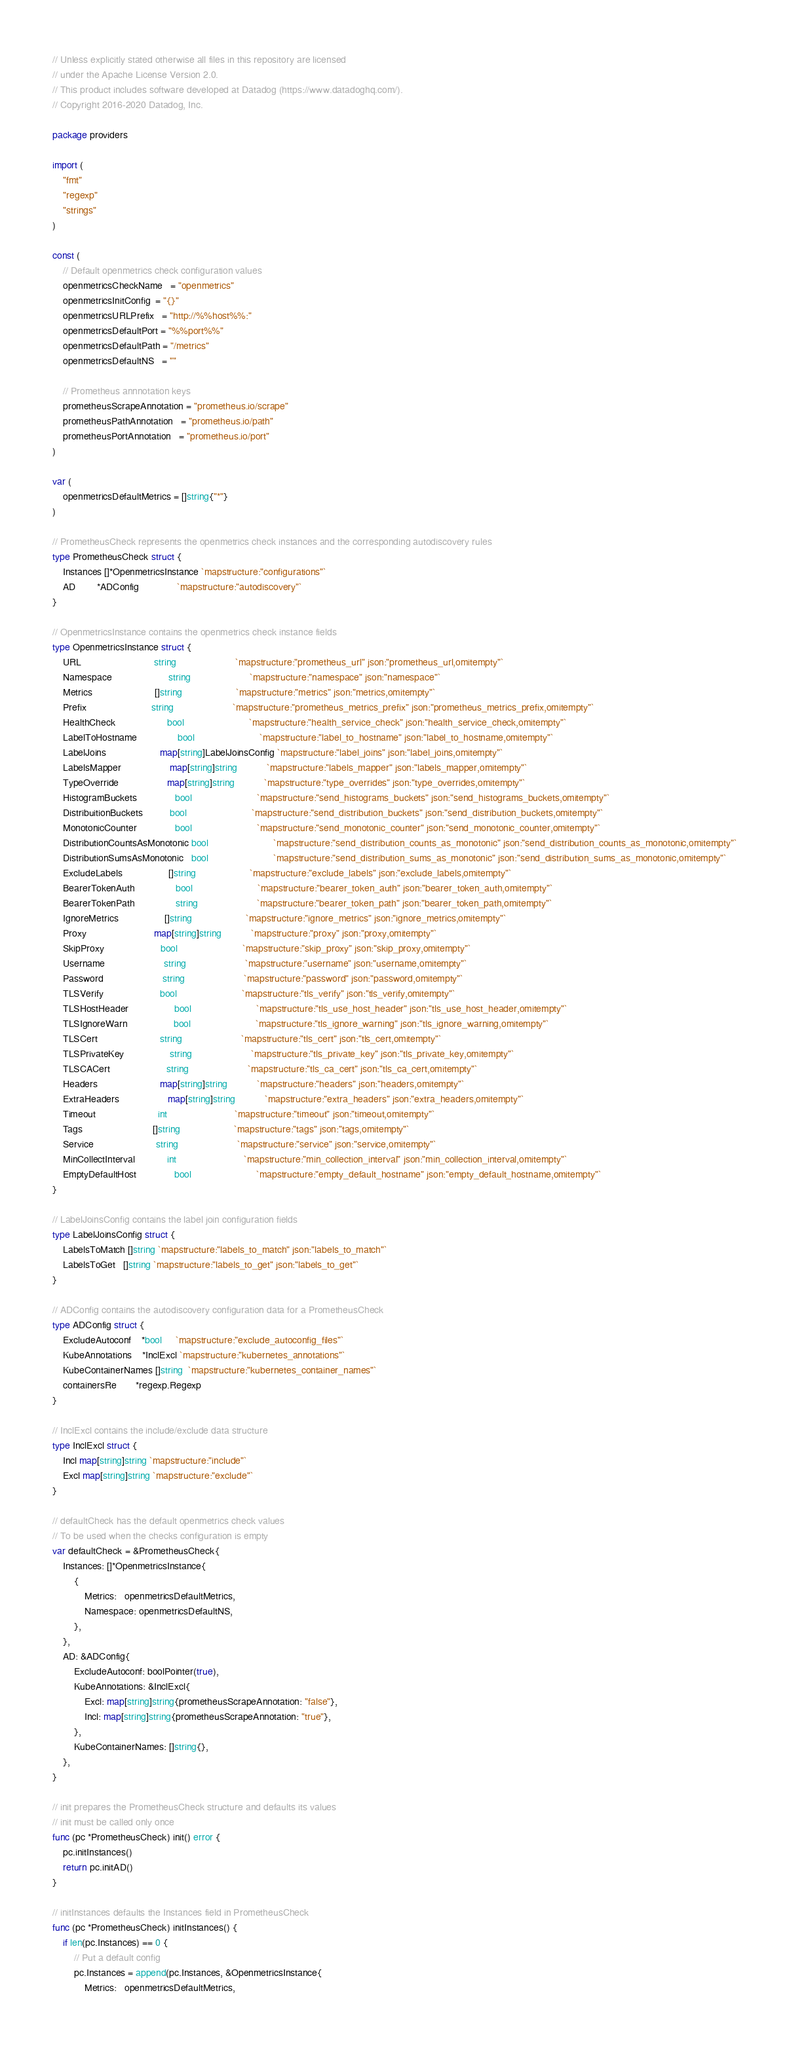Convert code to text. <code><loc_0><loc_0><loc_500><loc_500><_Go_>// Unless explicitly stated otherwise all files in this repository are licensed
// under the Apache License Version 2.0.
// This product includes software developed at Datadog (https://www.datadoghq.com/).
// Copyright 2016-2020 Datadog, Inc.

package providers

import (
	"fmt"
	"regexp"
	"strings"
)

const (
	// Default openmetrics check configuration values
	openmetricsCheckName   = "openmetrics"
	openmetricsInitConfig  = "{}"
	openmetricsURLPrefix   = "http://%%host%%:"
	openmetricsDefaultPort = "%%port%%"
	openmetricsDefaultPath = "/metrics"
	openmetricsDefaultNS   = ""

	// Prometheus annnotation keys
	prometheusScrapeAnnotation = "prometheus.io/scrape"
	prometheusPathAnnotation   = "prometheus.io/path"
	prometheusPortAnnotation   = "prometheus.io/port"
)

var (
	openmetricsDefaultMetrics = []string{"*"}
)

// PrometheusCheck represents the openmetrics check instances and the corresponding autodiscovery rules
type PrometheusCheck struct {
	Instances []*OpenmetricsInstance `mapstructure:"configurations"`
	AD        *ADConfig              `mapstructure:"autodiscovery"`
}

// OpenmetricsInstance contains the openmetrics check instance fields
type OpenmetricsInstance struct {
	URL                           string                      `mapstructure:"prometheus_url" json:"prometheus_url,omitempty"`
	Namespace                     string                      `mapstructure:"namespace" json:"namespace"`
	Metrics                       []string                    `mapstructure:"metrics" json:"metrics,omitempty"`
	Prefix                        string                      `mapstructure:"prometheus_metrics_prefix" json:"prometheus_metrics_prefix,omitempty"`
	HealthCheck                   bool                        `mapstructure:"health_service_check" json:"health_service_check,omitempty"`
	LabelToHostname               bool                        `mapstructure:"label_to_hostname" json:"label_to_hostname,omitempty"`
	LabelJoins                    map[string]LabelJoinsConfig `mapstructure:"label_joins" json:"label_joins,omitempty"`
	LabelsMapper                  map[string]string           `mapstructure:"labels_mapper" json:"labels_mapper,omitempty"`
	TypeOverride                  map[string]string           `mapstructure:"type_overrides" json:"type_overrides,omitempty"`
	HistogramBuckets              bool                        `mapstructure:"send_histograms_buckets" json:"send_histograms_buckets,omitempty"`
	DistribuitionBuckets          bool                        `mapstructure:"send_distribution_buckets" json:"send_distribution_buckets,omitempty"`
	MonotonicCounter              bool                        `mapstructure:"send_monotonic_counter" json:"send_monotonic_counter,omitempty"`
	DistributionCountsAsMonotonic bool                        `mapstructure:"send_distribution_counts_as_monotonic" json:"send_distribution_counts_as_monotonic,omitempty"`
	DistributionSumsAsMonotonic   bool                        `mapstructure:"send_distribution_sums_as_monotonic" json:"send_distribution_sums_as_monotonic,omitempty"`
	ExcludeLabels                 []string                    `mapstructure:"exclude_labels" json:"exclude_labels,omitempty"`
	BearerTokenAuth               bool                        `mapstructure:"bearer_token_auth" json:"bearer_token_auth,omitempty"`
	BearerTokenPath               string                      `mapstructure:"bearer_token_path" json:"bearer_token_path,omitempty"`
	IgnoreMetrics                 []string                    `mapstructure:"ignore_metrics" json:"ignore_metrics,omitempty"`
	Proxy                         map[string]string           `mapstructure:"proxy" json:"proxy,omitempty"`
	SkipProxy                     bool                        `mapstructure:"skip_proxy" json:"skip_proxy,omitempty"`
	Username                      string                      `mapstructure:"username" json:"username,omitempty"`
	Password                      string                      `mapstructure:"password" json:"password,omitempty"`
	TLSVerify                     bool                        `mapstructure:"tls_verify" json:"tls_verify,omitempty"`
	TLSHostHeader                 bool                        `mapstructure:"tls_use_host_header" json:"tls_use_host_header,omitempty"`
	TLSIgnoreWarn                 bool                        `mapstructure:"tls_ignore_warning" json:"tls_ignore_warning,omitempty"`
	TLSCert                       string                      `mapstructure:"tls_cert" json:"tls_cert,omitempty"`
	TLSPrivateKey                 string                      `mapstructure:"tls_private_key" json:"tls_private_key,omitempty"`
	TLSCACert                     string                      `mapstructure:"tls_ca_cert" json:"tls_ca_cert,omitempty"`
	Headers                       map[string]string           `mapstructure:"headers" json:"headers,omitempty"`
	ExtraHeaders                  map[string]string           `mapstructure:"extra_headers" json:"extra_headers,omitempty"`
	Timeout                       int                         `mapstructure:"timeout" json:"timeout,omitempty"`
	Tags                          []string                    `mapstructure:"tags" json:"tags,omitempty"`
	Service                       string                      `mapstructure:"service" json:"service,omitempty"`
	MinCollectInterval            int                         `mapstructure:"min_collection_interval" json:"min_collection_interval,omitempty"`
	EmptyDefaultHost              bool                        `mapstructure:"empty_default_hostname" json:"empty_default_hostname,omitempty"`
}

// LabelJoinsConfig contains the label join configuration fields
type LabelJoinsConfig struct {
	LabelsToMatch []string `mapstructure:"labels_to_match" json:"labels_to_match"`
	LabelsToGet   []string `mapstructure:"labels_to_get" json:"labels_to_get"`
}

// ADConfig contains the autodiscovery configuration data for a PrometheusCheck
type ADConfig struct {
	ExcludeAutoconf    *bool     `mapstructure:"exclude_autoconfig_files"`
	KubeAnnotations    *InclExcl `mapstructure:"kubernetes_annotations"`
	KubeContainerNames []string  `mapstructure:"kubernetes_container_names"`
	containersRe       *regexp.Regexp
}

// InclExcl contains the include/exclude data structure
type InclExcl struct {
	Incl map[string]string `mapstructure:"include"`
	Excl map[string]string `mapstructure:"exclude"`
}

// defaultCheck has the default openmetrics check values
// To be used when the checks configuration is empty
var defaultCheck = &PrometheusCheck{
	Instances: []*OpenmetricsInstance{
		{
			Metrics:   openmetricsDefaultMetrics,
			Namespace: openmetricsDefaultNS,
		},
	},
	AD: &ADConfig{
		ExcludeAutoconf: boolPointer(true),
		KubeAnnotations: &InclExcl{
			Excl: map[string]string{prometheusScrapeAnnotation: "false"},
			Incl: map[string]string{prometheusScrapeAnnotation: "true"},
		},
		KubeContainerNames: []string{},
	},
}

// init prepares the PrometheusCheck structure and defaults its values
// init must be called only once
func (pc *PrometheusCheck) init() error {
	pc.initInstances()
	return pc.initAD()
}

// initInstances defaults the Instances field in PrometheusCheck
func (pc *PrometheusCheck) initInstances() {
	if len(pc.Instances) == 0 {
		// Put a default config
		pc.Instances = append(pc.Instances, &OpenmetricsInstance{
			Metrics:   openmetricsDefaultMetrics,</code> 